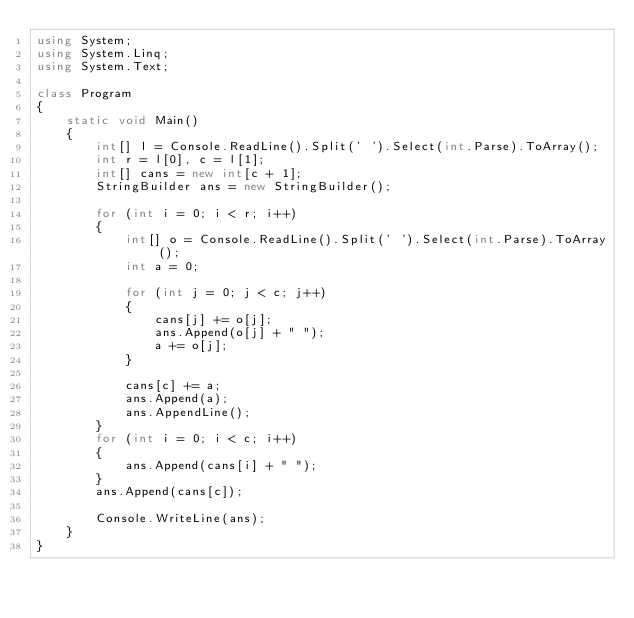<code> <loc_0><loc_0><loc_500><loc_500><_C#_>using System;
using System.Linq;
using System.Text;

class Program
{
    static void Main()
    {
        int[] l = Console.ReadLine().Split(' ').Select(int.Parse).ToArray();
        int r = l[0], c = l[1];
        int[] cans = new int[c + 1];
        StringBuilder ans = new StringBuilder();

        for (int i = 0; i < r; i++)
        {
            int[] o = Console.ReadLine().Split(' ').Select(int.Parse).ToArray();
            int a = 0;

            for (int j = 0; j < c; j++)
            {
                cans[j] += o[j];
                ans.Append(o[j] + " ");
                a += o[j];
            }

            cans[c] += a;
            ans.Append(a);
            ans.AppendLine();
        }
        for (int i = 0; i < c; i++)
        {
            ans.Append(cans[i] + " ");
        }
        ans.Append(cans[c]);

        Console.WriteLine(ans);
    }
}</code> 